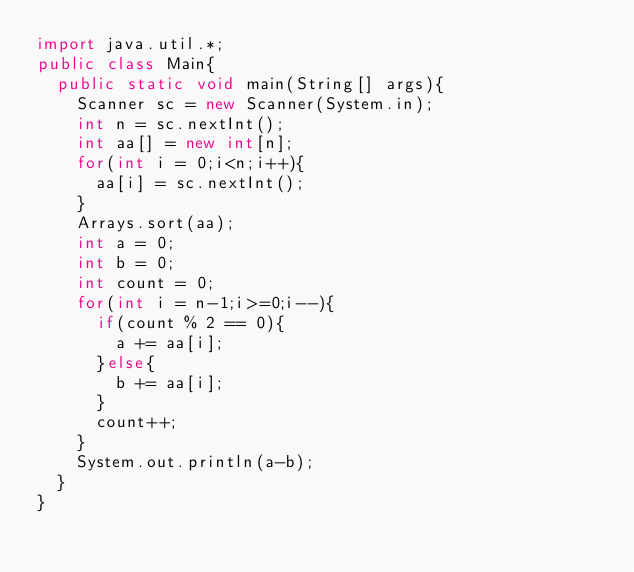<code> <loc_0><loc_0><loc_500><loc_500><_Java_>import java.util.*;
public class Main{
  public static void main(String[] args){
    Scanner sc = new Scanner(System.in);
    int n = sc.nextInt();
    int aa[] = new int[n];
    for(int i = 0;i<n;i++){
      aa[i] = sc.nextInt();
    }
    Arrays.sort(aa);
    int a = 0;
    int b = 0;
    int count = 0;
    for(int i = n-1;i>=0;i--){
      if(count % 2 == 0){
        a += aa[i];
      }else{
        b += aa[i];
      }
      count++;
    }
    System.out.println(a-b);
  }
}
</code> 